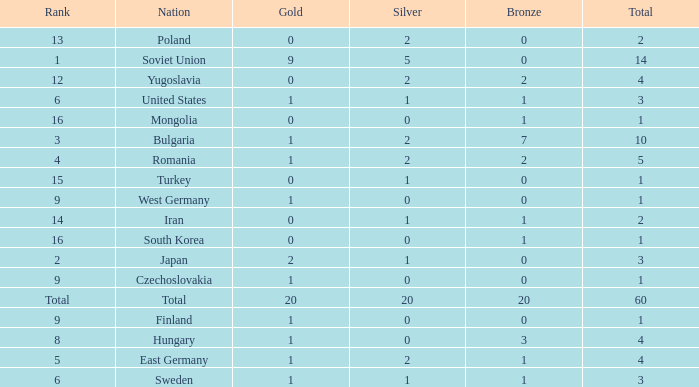What is the sum of bronzes having silvers over 5 and golds under 20? None. 